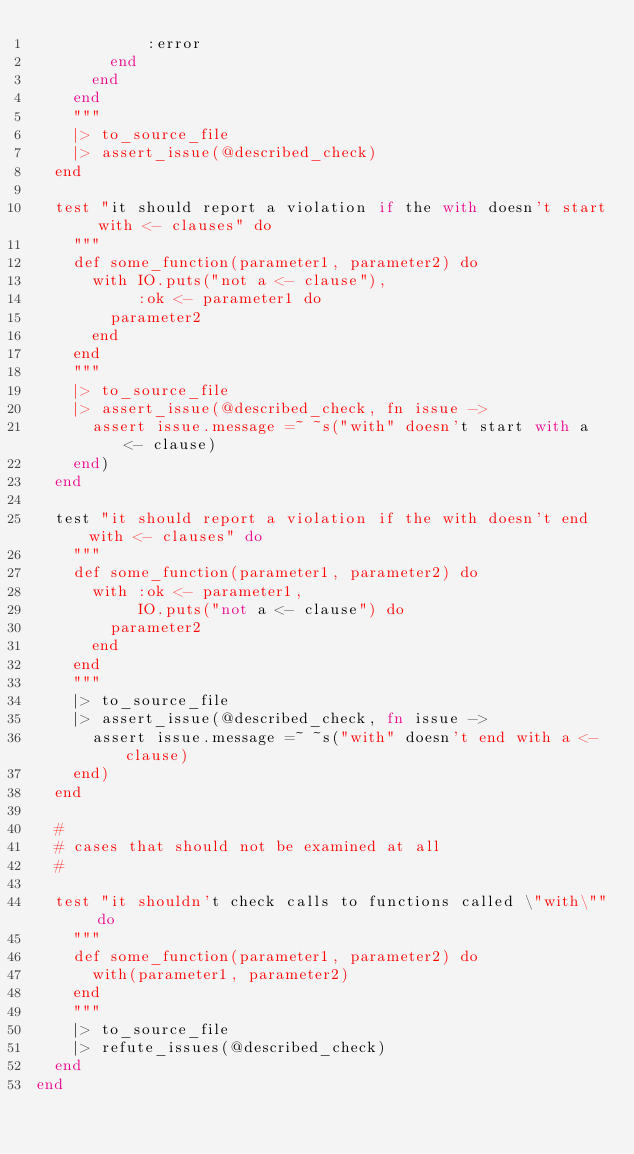<code> <loc_0><loc_0><loc_500><loc_500><_Elixir_>            :error
        end
      end
    end
    """
    |> to_source_file
    |> assert_issue(@described_check)
  end

  test "it should report a violation if the with doesn't start with <- clauses" do
    """
    def some_function(parameter1, parameter2) do
      with IO.puts("not a <- clause"),
           :ok <- parameter1 do
        parameter2
      end
    end
    """
    |> to_source_file
    |> assert_issue(@described_check, fn issue ->
      assert issue.message =~ ~s("with" doesn't start with a <- clause)
    end)
  end

  test "it should report a violation if the with doesn't end with <- clauses" do
    """
    def some_function(parameter1, parameter2) do
      with :ok <- parameter1,
           IO.puts("not a <- clause") do
        parameter2
      end
    end
    """
    |> to_source_file
    |> assert_issue(@described_check, fn issue ->
      assert issue.message =~ ~s("with" doesn't end with a <- clause)
    end)
  end

  #
  # cases that should not be examined at all
  #

  test "it shouldn't check calls to functions called \"with\"" do
    """
    def some_function(parameter1, parameter2) do
      with(parameter1, parameter2)
    end
    """
    |> to_source_file
    |> refute_issues(@described_check)
  end
end
</code> 